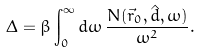<formula> <loc_0><loc_0><loc_500><loc_500>\Delta = \beta \int _ { 0 } ^ { \infty } d \omega \, \frac { N ( \vec { r } _ { 0 } , \hat { d } , \omega ) } { \omega ^ { 2 } } .</formula> 